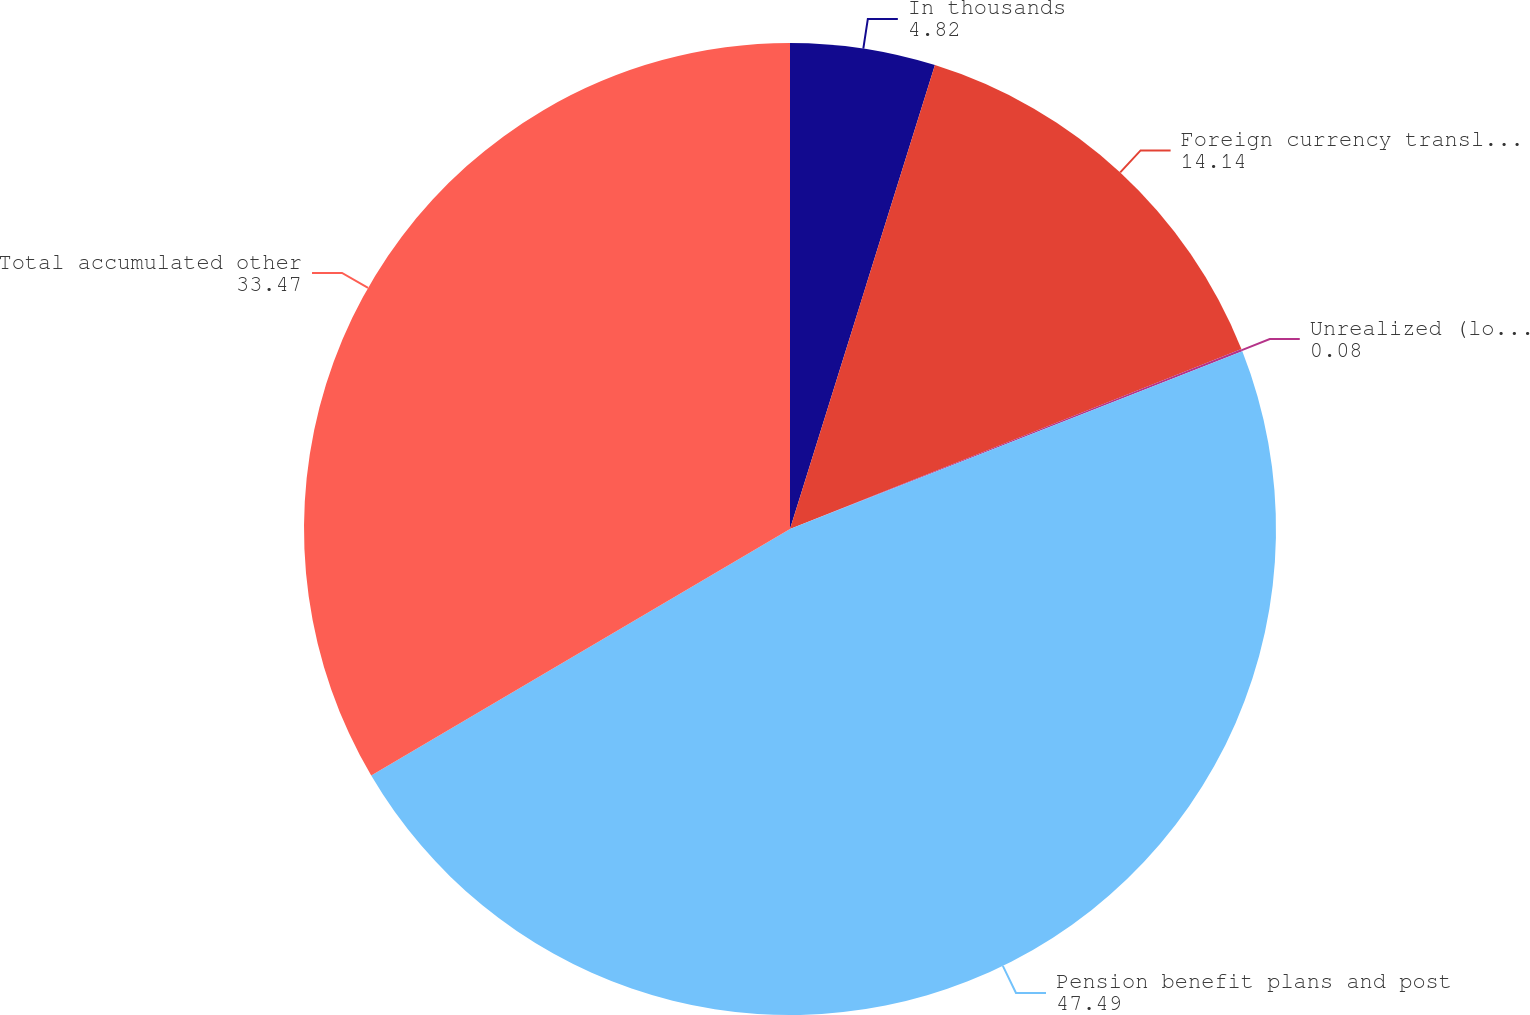Convert chart to OTSL. <chart><loc_0><loc_0><loc_500><loc_500><pie_chart><fcel>In thousands<fcel>Foreign currency translation<fcel>Unrealized (loss) gain on<fcel>Pension benefit plans and post<fcel>Total accumulated other<nl><fcel>4.82%<fcel>14.14%<fcel>0.08%<fcel>47.49%<fcel>33.47%<nl></chart> 